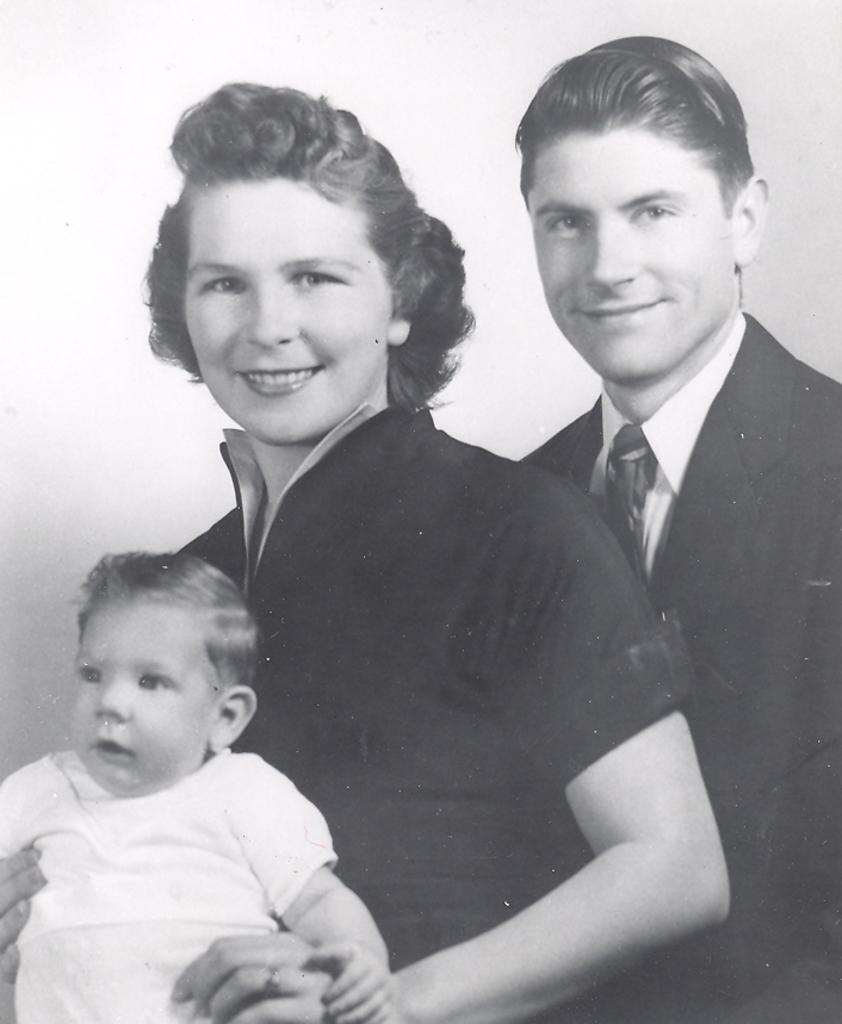What is the color scheme of the image? The image is black and white. How many people are in the image? There are three people in the image: one man, one woman, and a kid. What can be seen in the background of the image? There is white color visible in the background of the image. What is the profession of the fireman in the image? There is no fireman present in the image; it features a man, a woman, and a kid. What is the birth date of the person in the image? The image does not provide any information about the birth date of the people in the image. 